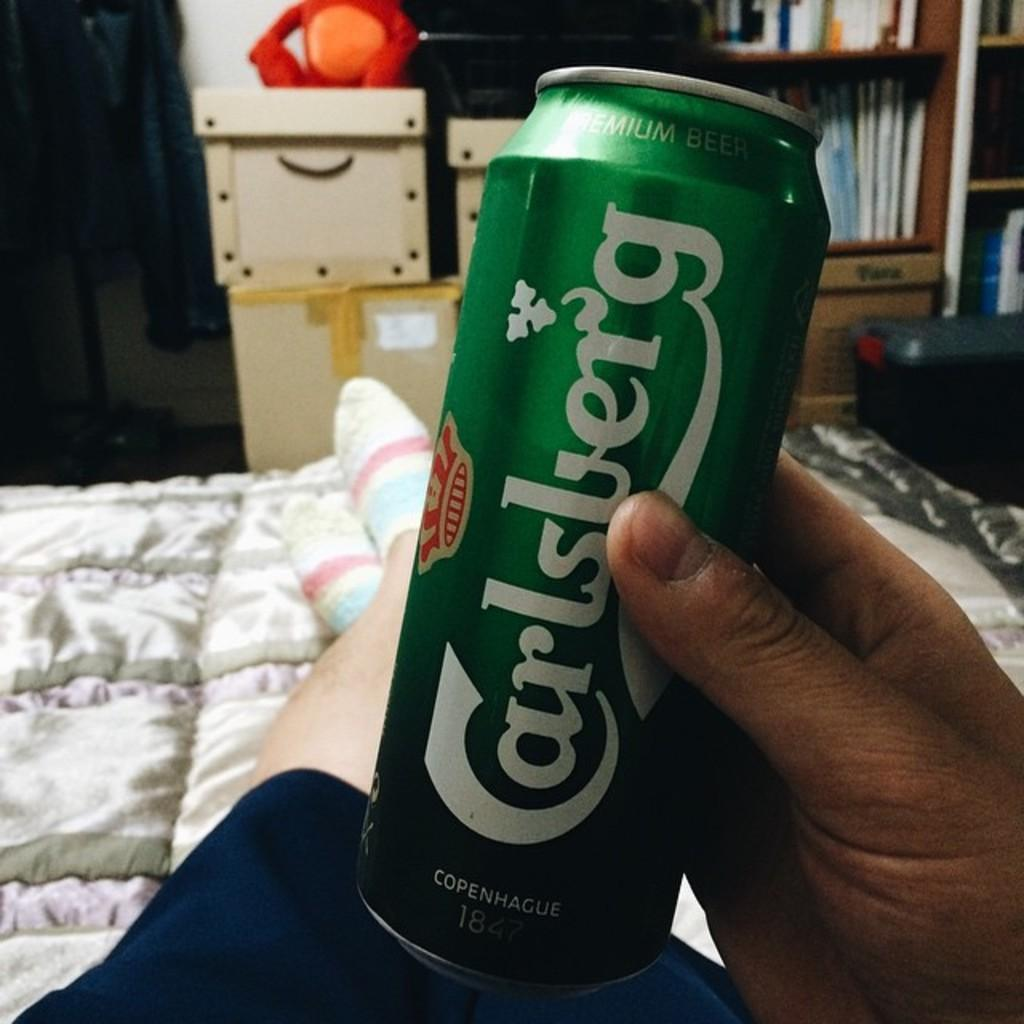Provide a one-sentence caption for the provided image. A green Carlsberg Premium Beer can is being held by somebody lounging in bed. 